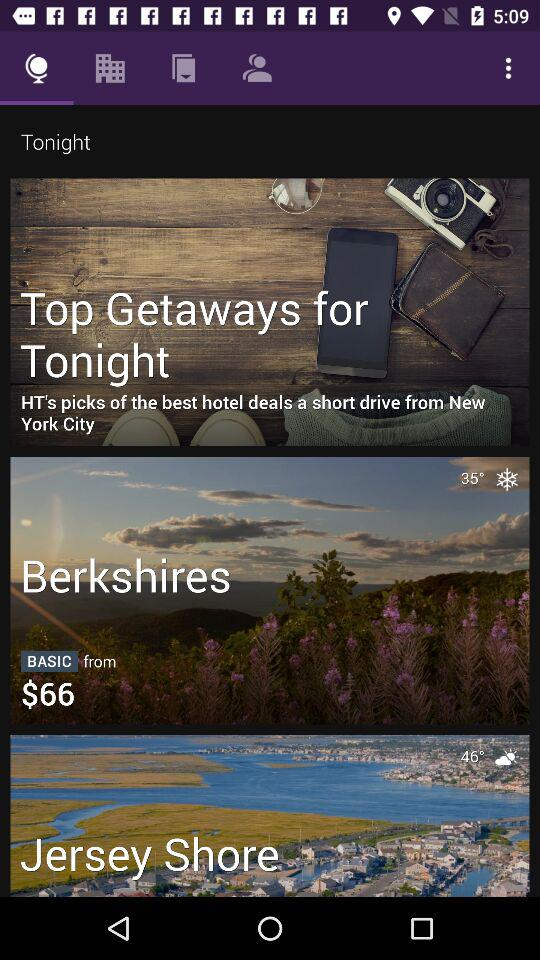What is the booking price of a hotel room in the Berkshires? The booking price of a hotel room in the Berkshires starts at $66. 